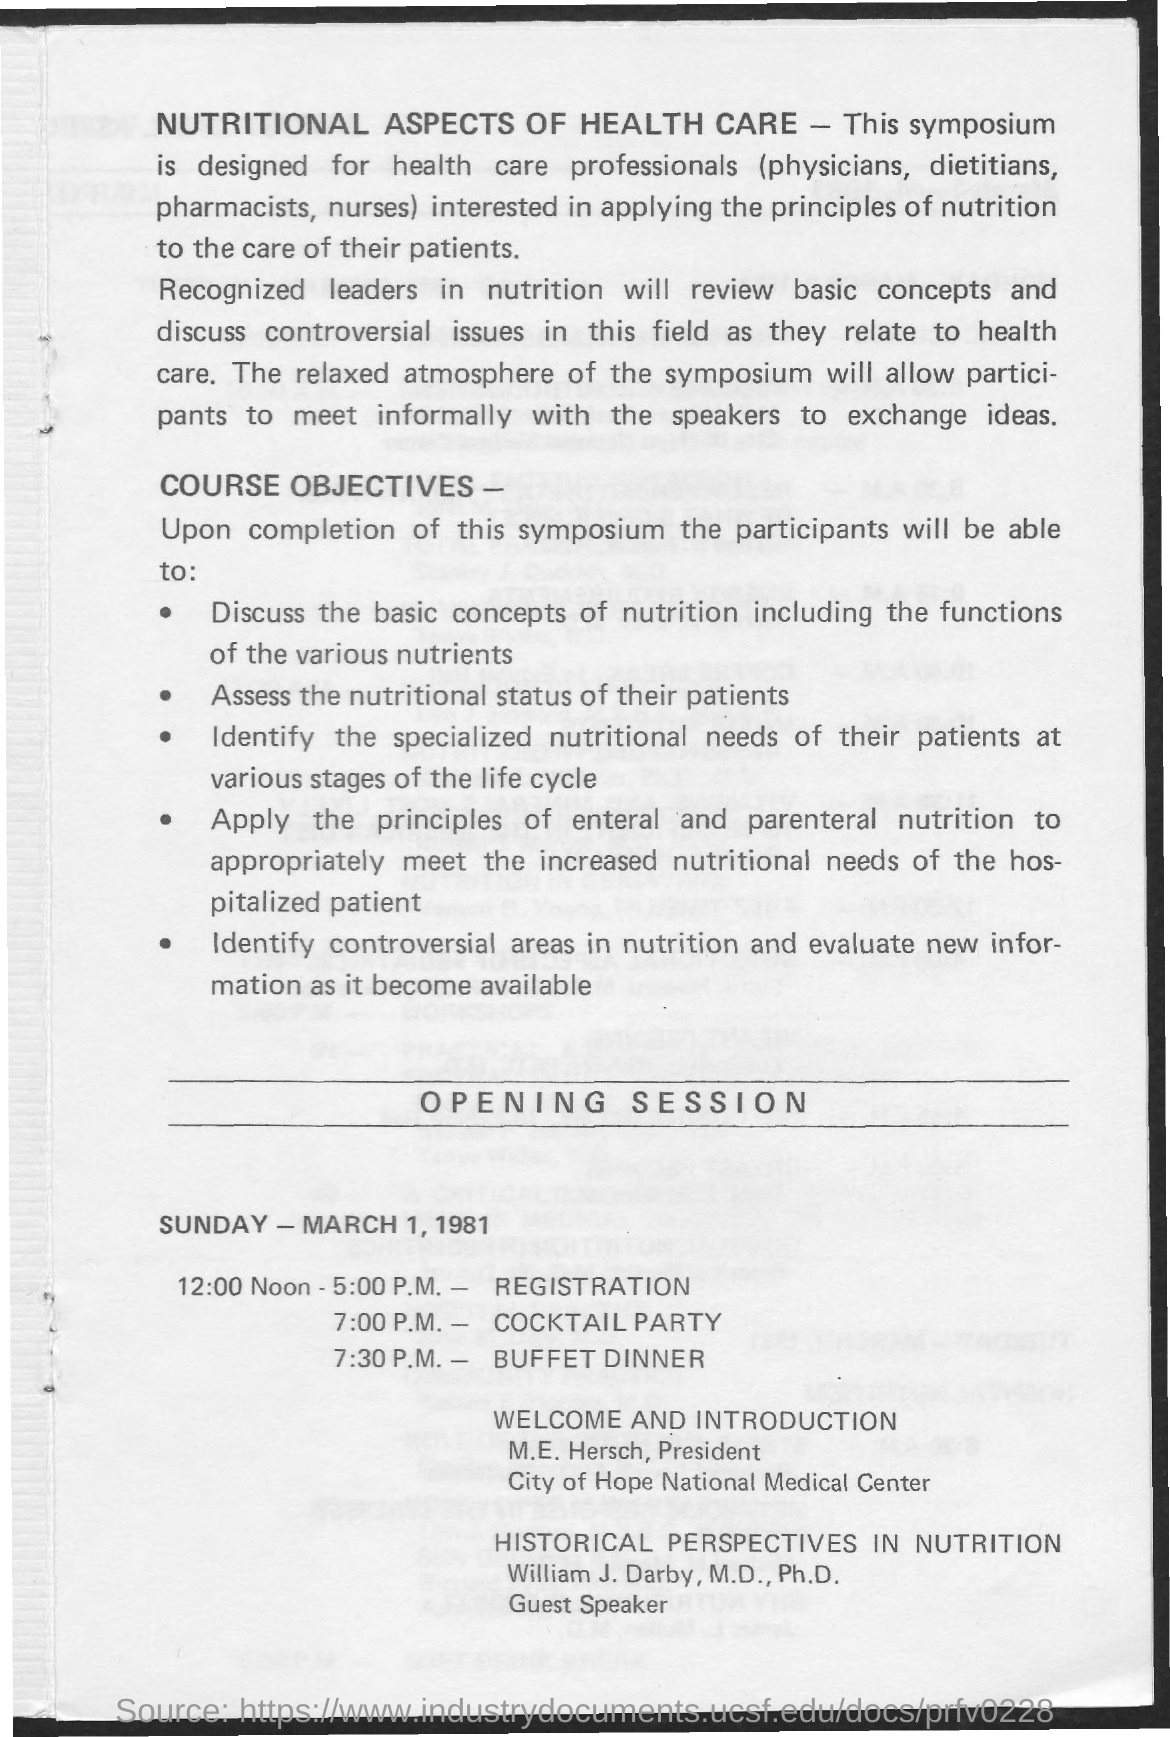Who is the president of city of hope national medical center?
Offer a terse response. M.E. Hersch. Who is the guest speaker?
Your answer should be compact. William J. Darby. What is the heading of page?
Offer a terse response. Nutritional Aspects of Health Care. What day of the week is mentioned in the opening session?
Keep it short and to the point. Sunday. What is the time scheduled for registration?
Give a very brief answer. 12:00 Noon - 5:00 p.m. 